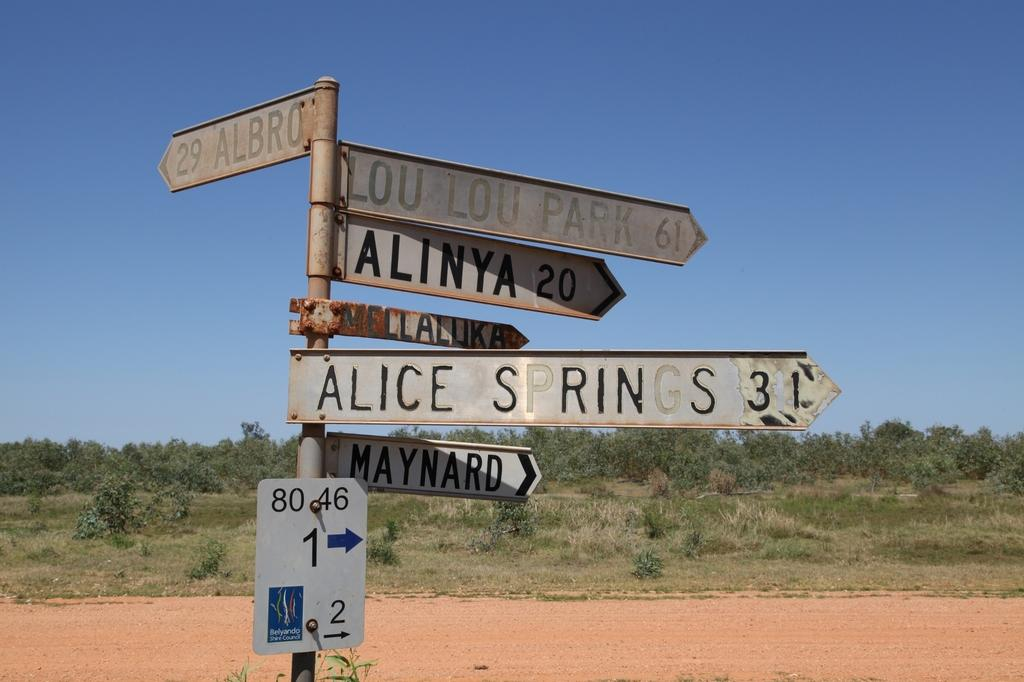<image>
Present a compact description of the photo's key features. A cluster of directional signs showing that Maynard and Alice Springs are to the right. 